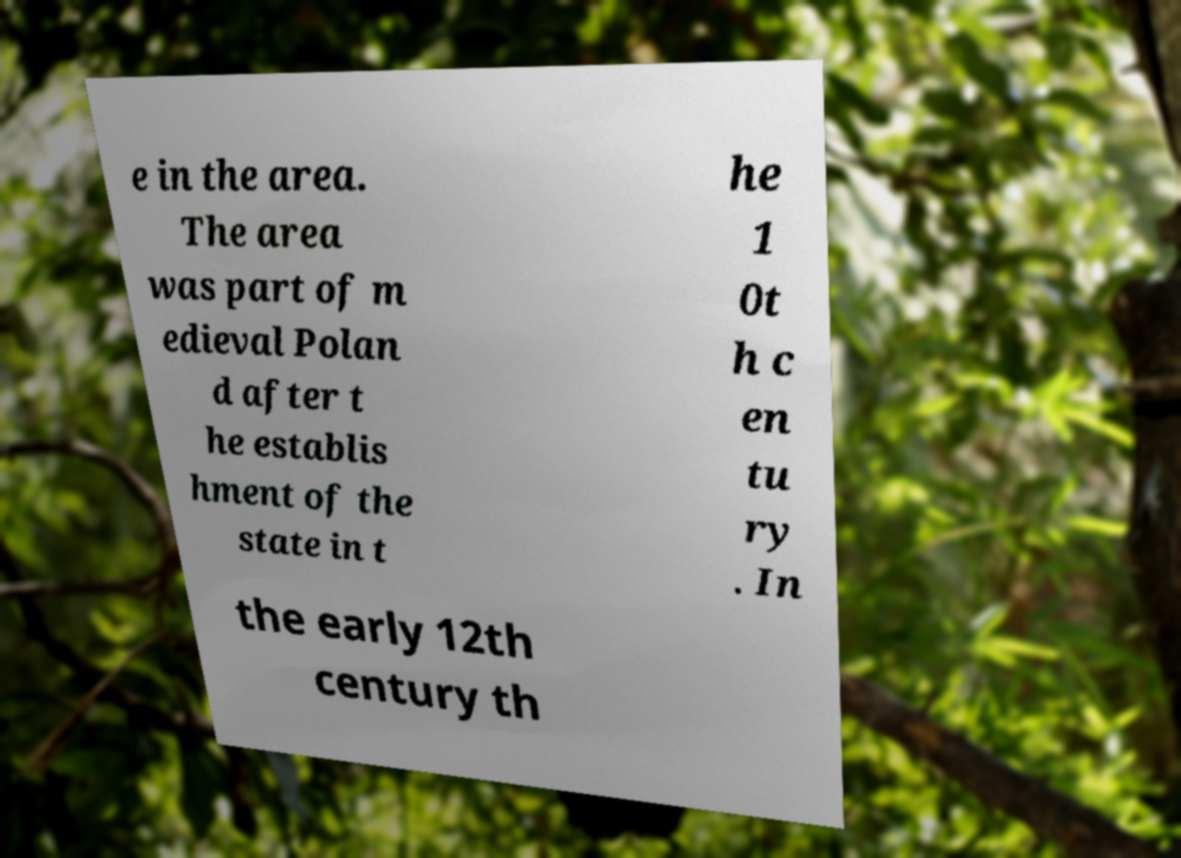What messages or text are displayed in this image? I need them in a readable, typed format. e in the area. The area was part of m edieval Polan d after t he establis hment of the state in t he 1 0t h c en tu ry . In the early 12th century th 